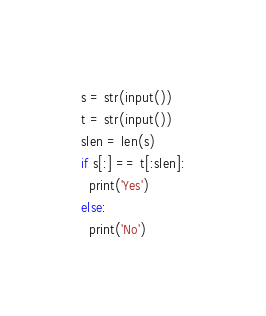Convert code to text. <code><loc_0><loc_0><loc_500><loc_500><_Python_>s = str(input())
t = str(input())
slen = len(s)
if s[:] == t[:slen]:
  print('Yes')
else:
  print('No')</code> 